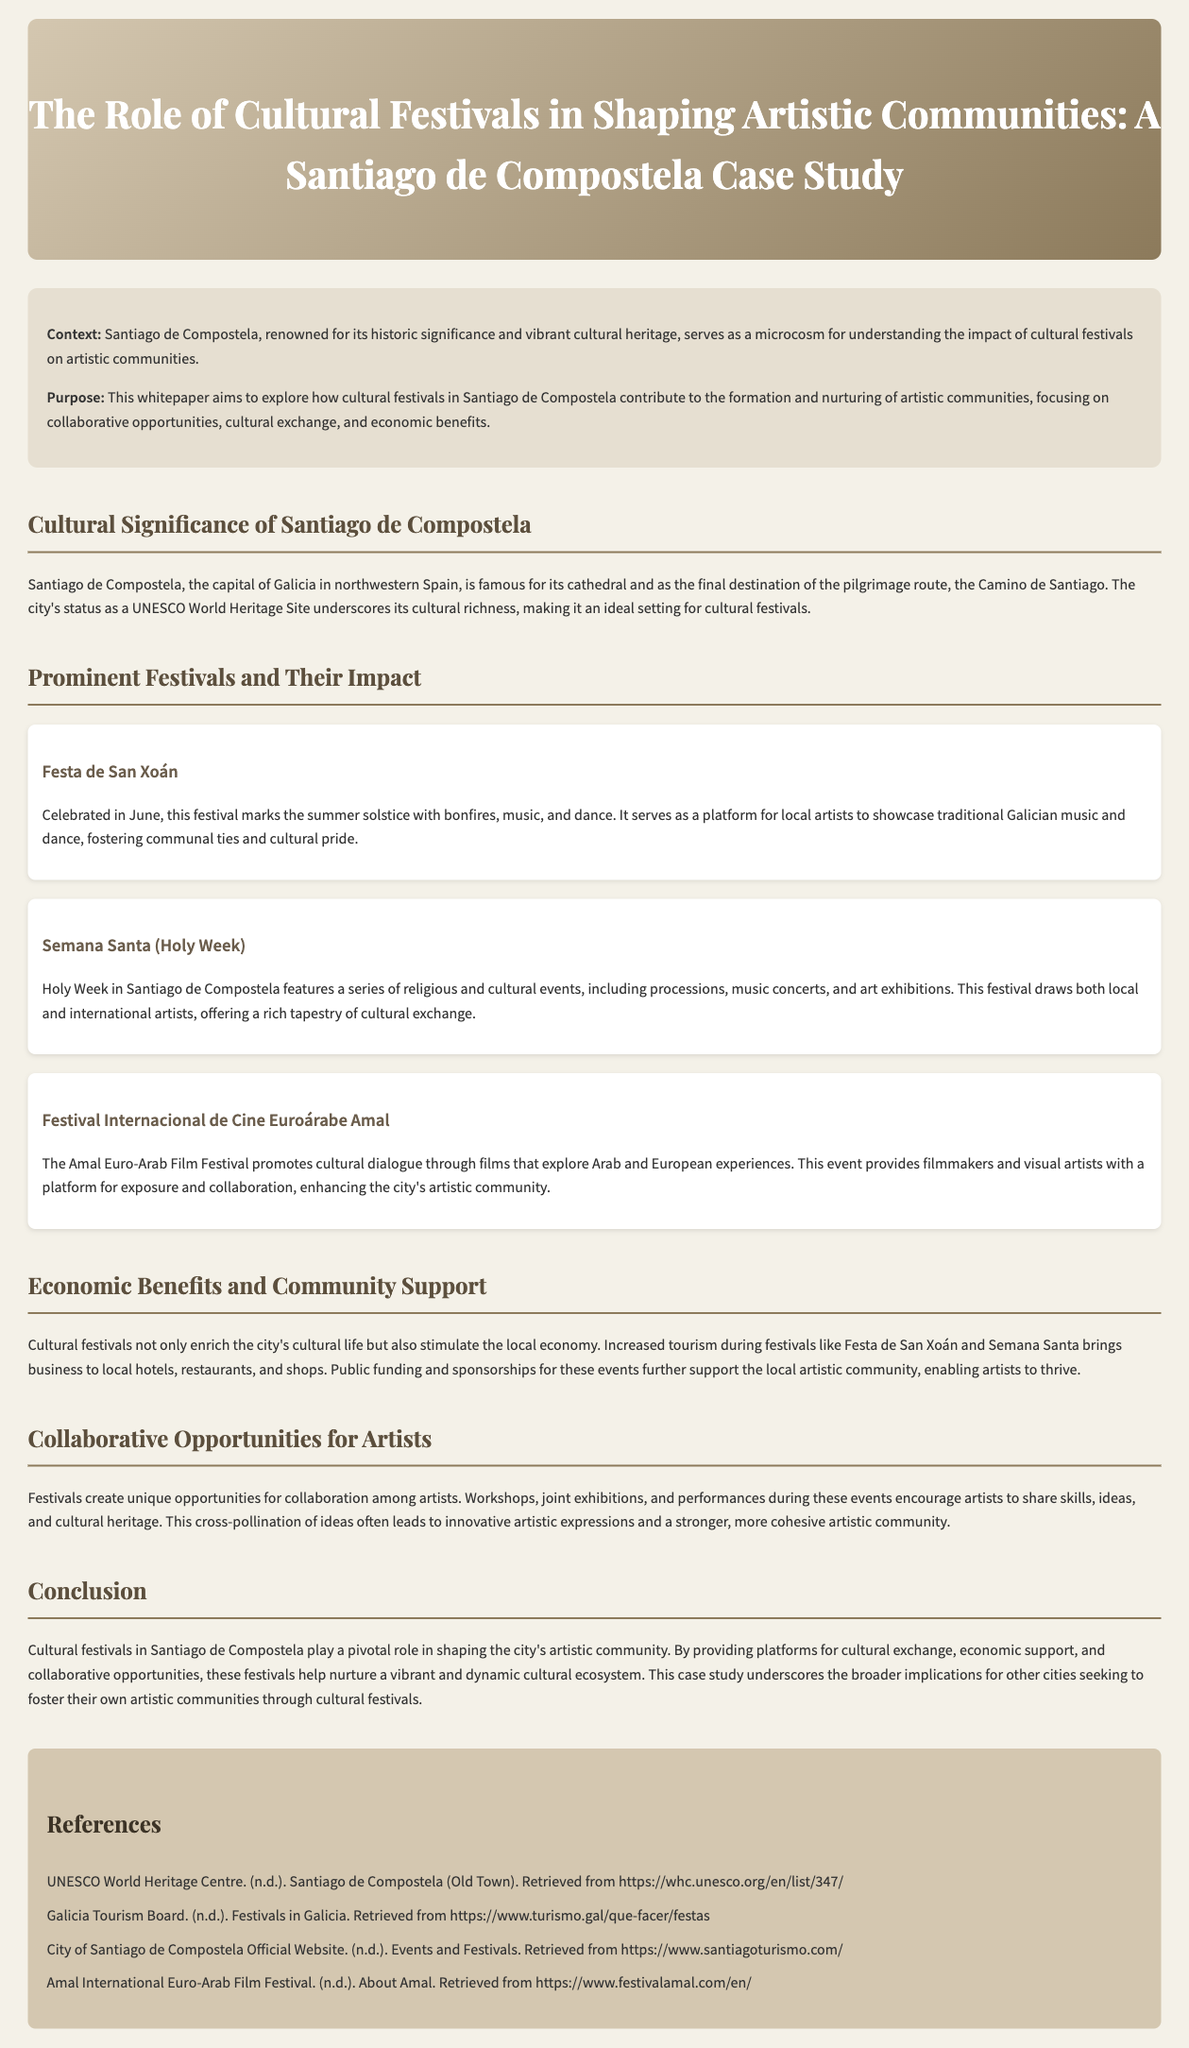What is the capital of Galicia? The document states that Santiago de Compostela is the capital of Galicia in northwestern Spain.
Answer: Santiago de Compostela Which UNESCO designation does Santiago de Compostela hold? The whitepaper mentions that Santiago de Compostela is a UNESCO World Heritage Site, highlighting its cultural richness.
Answer: UNESCO World Heritage Site What festival marks the summer solstice? The document specifies that the Festa de San Xoán is celebrated in June and marks the summer solstice.
Answer: Festa de San Xoán What type of events does Semana Santa feature? According to the document, Semana Santa includes processions, music concerts, and art exhibitions.
Answer: Processions, music concerts, and art exhibitions What economic benefit do cultural festivals bring to local businesses? The whitepaper outlines that cultural festivals increase tourism, which benefits local hotels, restaurants, and shops.
Answer: Increased tourism How do festivals provide opportunities for artists? The document explains that festivals create opportunities for collaboration among artists, leading to shared skills and ideas.
Answer: Collaboration among artists What is the focus of the Festival Internacional de Cine Euroárabe Amal? The whitepaper describes this festival as promoting cultural dialogue through films that explore Arab and European experiences.
Answer: Cultural dialogue What impact do festivals have on the local artistic community? The conclusion of the document states that festivals play a pivotal role in shaping the city's artistic community by nurturing a vibrant cultural ecosystem.
Answer: Nurturing a vibrant cultural ecosystem What is the purpose of this whitepaper? The document outlines that the purpose of the whitepaper is to explore how cultural festivals contribute to the formation and nurturing of artistic communities.
Answer: Explore how cultural festivals contribute to the formation and nurturing of artistic communities 